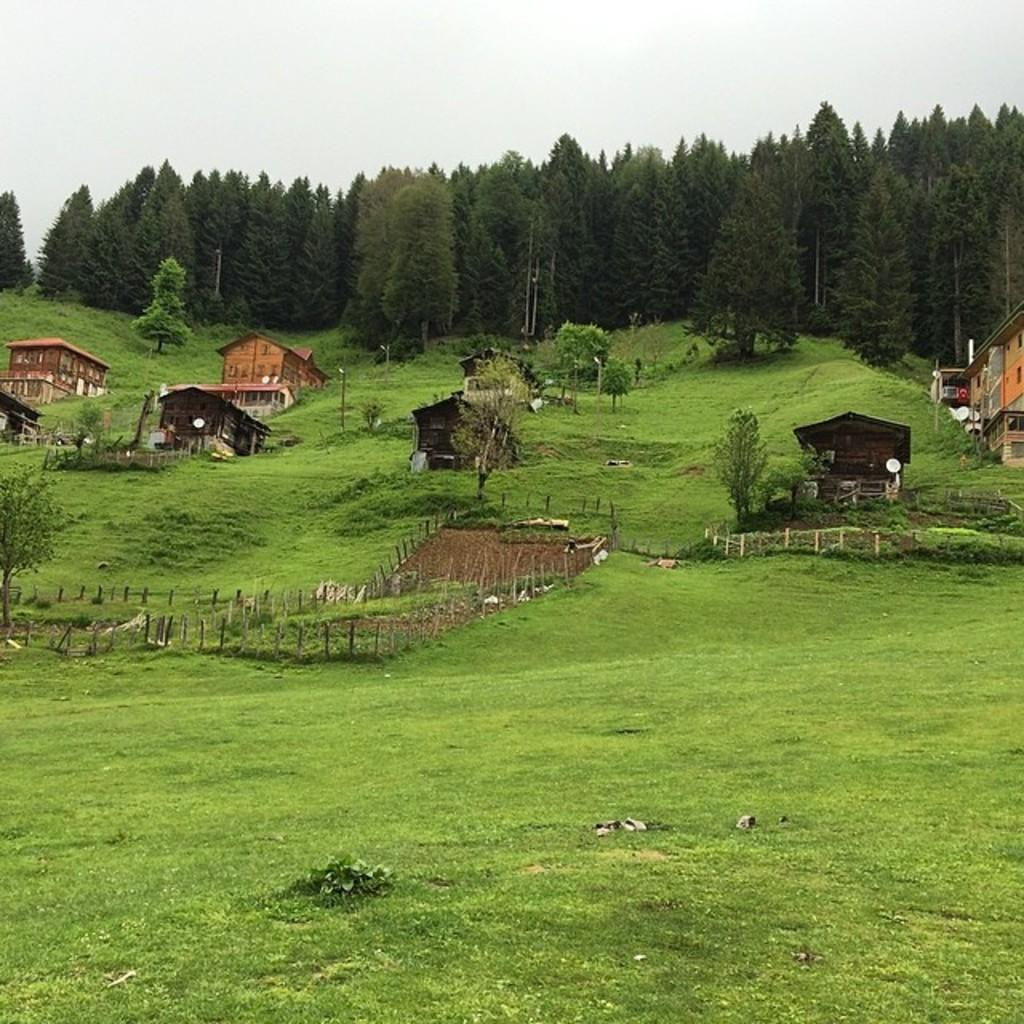What is the main feature of the landscape in the image? There is an open grass ground in the image. What can be seen in the distance behind the grass ground? There are trees and buildings in the background of the image. What structures are visible within the grass ground area? There are poles visible in the image. How many letters are being pushed by the person in the image? There is no person or letters present in the image. What type of rail can be seen connecting the poles in the image? There is no rail connecting the poles in the image. 